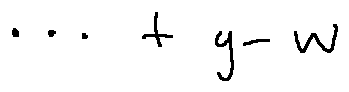Convert formula to latex. <formula><loc_0><loc_0><loc_500><loc_500>\cdots + g - w</formula> 